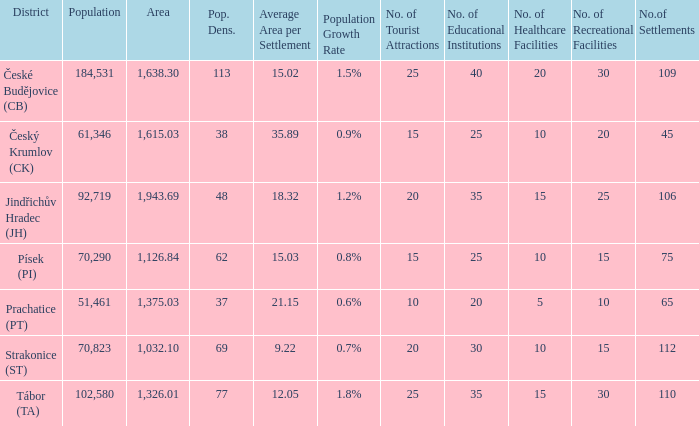What is the population density of the area with a population larger than 92,719? 2.0. 